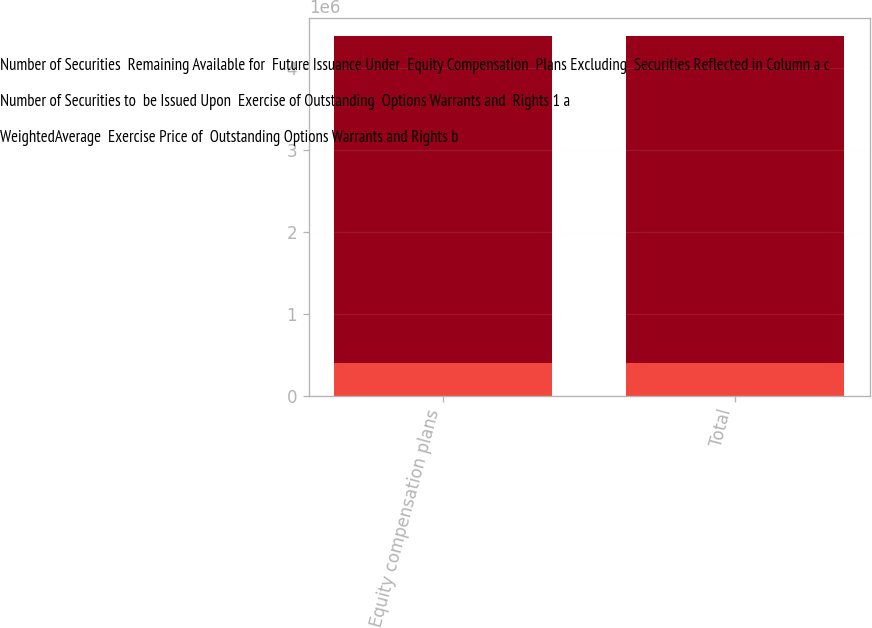<chart> <loc_0><loc_0><loc_500><loc_500><stacked_bar_chart><ecel><fcel>Equity compensation plans<fcel>Total<nl><fcel>Number of Securities  Remaining Available for  Future Issuance Under  Equity Compensation  Plans Excluding  Securities Reflected in Column a c<fcel>399165<fcel>399165<nl><fcel>Number of Securities to  be Issued Upon  Exercise of Outstanding  Options Warrants and  Rights 1 a<fcel>0<fcel>0<nl><fcel>WeightedAverage  Exercise Price of  Outstanding Options Warrants and Rights b<fcel>3.9956e+06<fcel>3.9956e+06<nl></chart> 